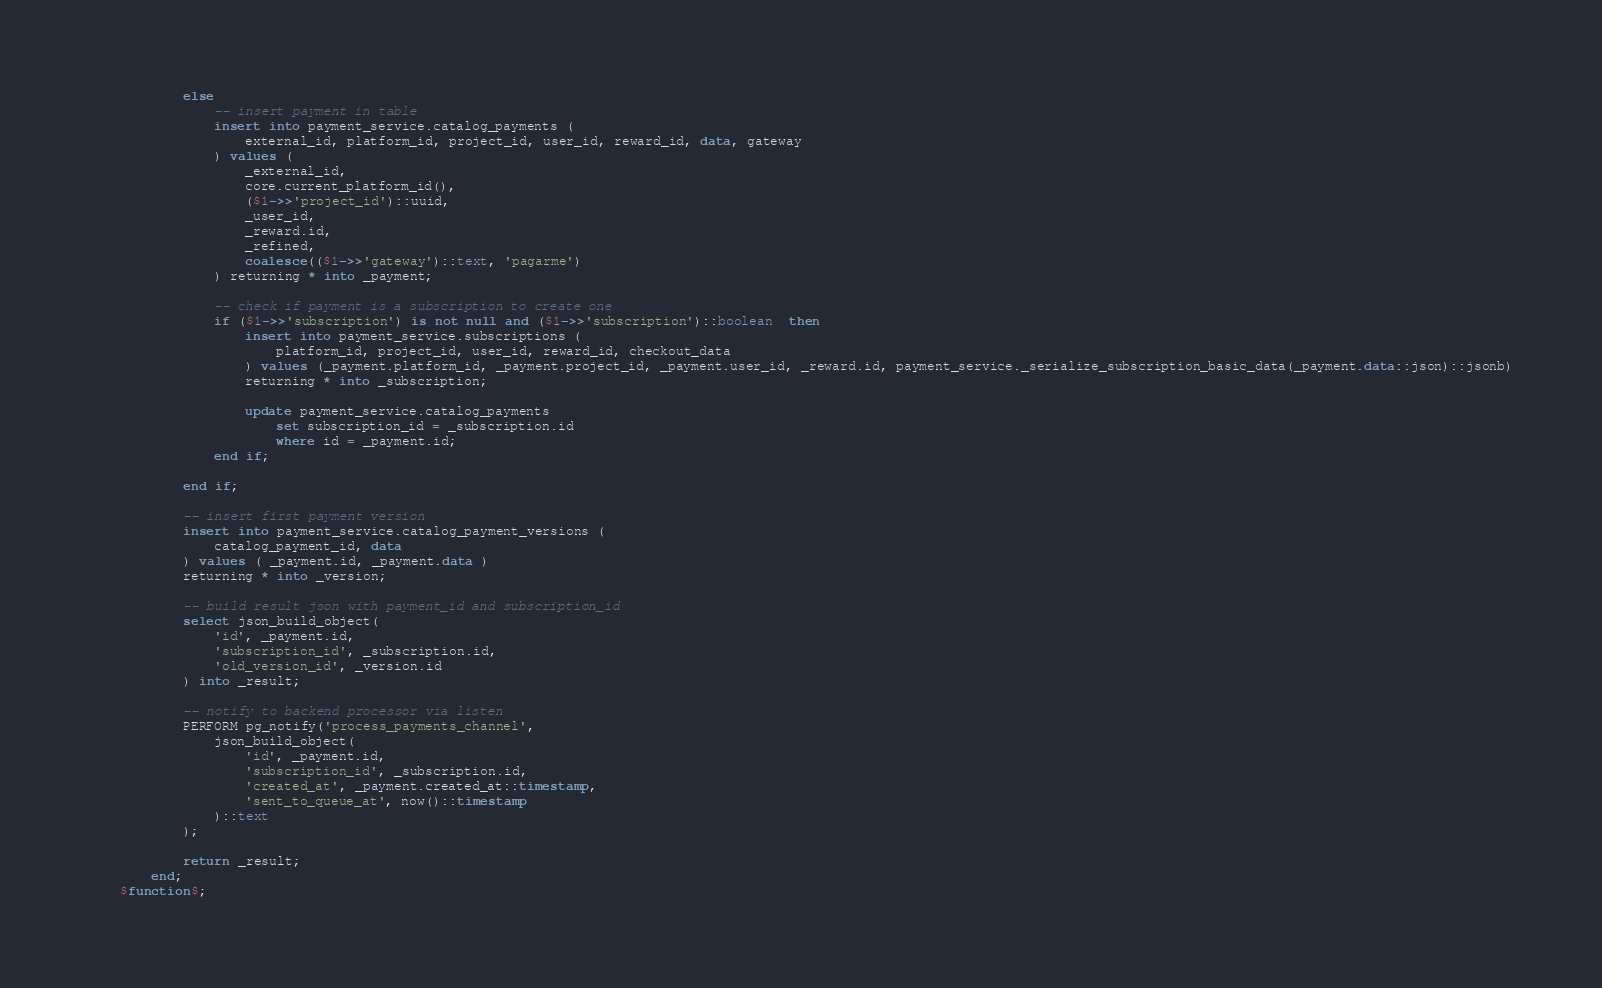Convert code to text. <code><loc_0><loc_0><loc_500><loc_500><_SQL_>            else
                -- insert payment in table
                insert into payment_service.catalog_payments (
                    external_id, platform_id, project_id, user_id, reward_id, data, gateway
                ) values (
                    _external_id,
                    core.current_platform_id(),
                    ($1->>'project_id')::uuid,
                    _user_id,
                    _reward.id,
                    _refined,
                    coalesce(($1->>'gateway')::text, 'pagarme')
                ) returning * into _payment;
    
                -- check if payment is a subscription to create one
                if ($1->>'subscription') is not null and ($1->>'subscription')::boolean  then
                    insert into payment_service.subscriptions (
                        platform_id, project_id, user_id, reward_id, checkout_data
                    ) values (_payment.platform_id, _payment.project_id, _payment.user_id, _reward.id, payment_service._serialize_subscription_basic_data(_payment.data::json)::jsonb)
                    returning * into _subscription;
    
                    update payment_service.catalog_payments
                        set subscription_id = _subscription.id
                        where id = _payment.id;
                end if;
                
            end if;
                
            -- insert first payment version
            insert into payment_service.catalog_payment_versions (
                catalog_payment_id, data
            ) values ( _payment.id, _payment.data )
            returning * into _version;

            -- build result json with payment_id and subscription_id
            select json_build_object(
                'id', _payment.id,
                'subscription_id', _subscription.id,
                'old_version_id', _version.id
            ) into _result;

            -- notify to backend processor via listen
            PERFORM pg_notify('process_payments_channel',
                json_build_object(
                    'id', _payment.id,
                    'subscription_id', _subscription.id,
                    'created_at', _payment.created_at::timestamp,
                    'sent_to_queue_at', now()::timestamp
                )::text
            );

            return _result;
        end;
    $function$;</code> 